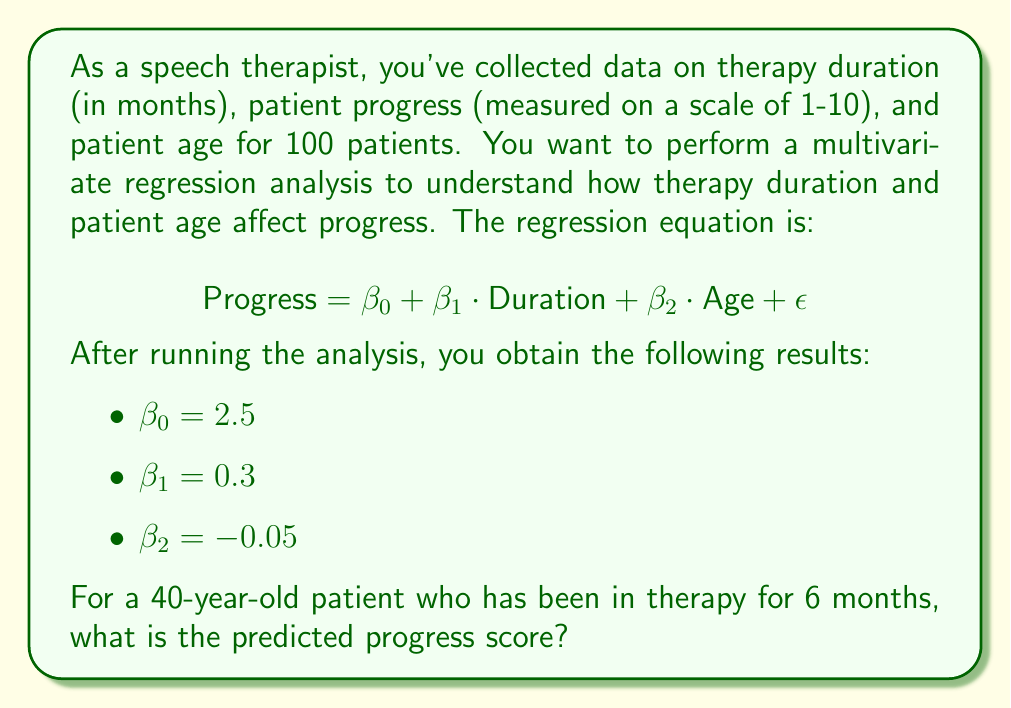Show me your answer to this math problem. To solve this problem, we'll follow these steps:

1. Understand the regression equation:
   $$\text{Progress} = \beta_0 + \beta_1 \cdot \text{Duration} + \beta_2 \cdot \text{Age} + \epsilon$$

   Where:
   - $\beta_0$ is the intercept (2.5)
   - $\beta_1$ is the coefficient for therapy duration (0.3)
   - $\beta_2$ is the coefficient for patient age (-0.05)
   - $\epsilon$ is the error term (which we ignore for prediction)

2. Substitute the given values:
   - Duration = 6 months
   - Age = 40 years

3. Calculate the predicted progress:

   $$\begin{align}
   \text{Progress} &= 2.5 + 0.3 \cdot \text{Duration} + (-0.05) \cdot \text{Age} \\
   &= 2.5 + 0.3 \cdot 6 + (-0.05) \cdot 40 \\
   &= 2.5 + 1.8 - 2 \\
   &= 2.3
   \end{align}$$

The predicted progress score for a 40-year-old patient who has been in therapy for 6 months is 2.3.

Interpretation:
- For each month of therapy, the progress score increases by 0.3 points.
- For each year of age, the progress score decreases by 0.05 points.
- The baseline progress score (intercept) is 2.5 points.
Answer: The predicted progress score is 2.3. 